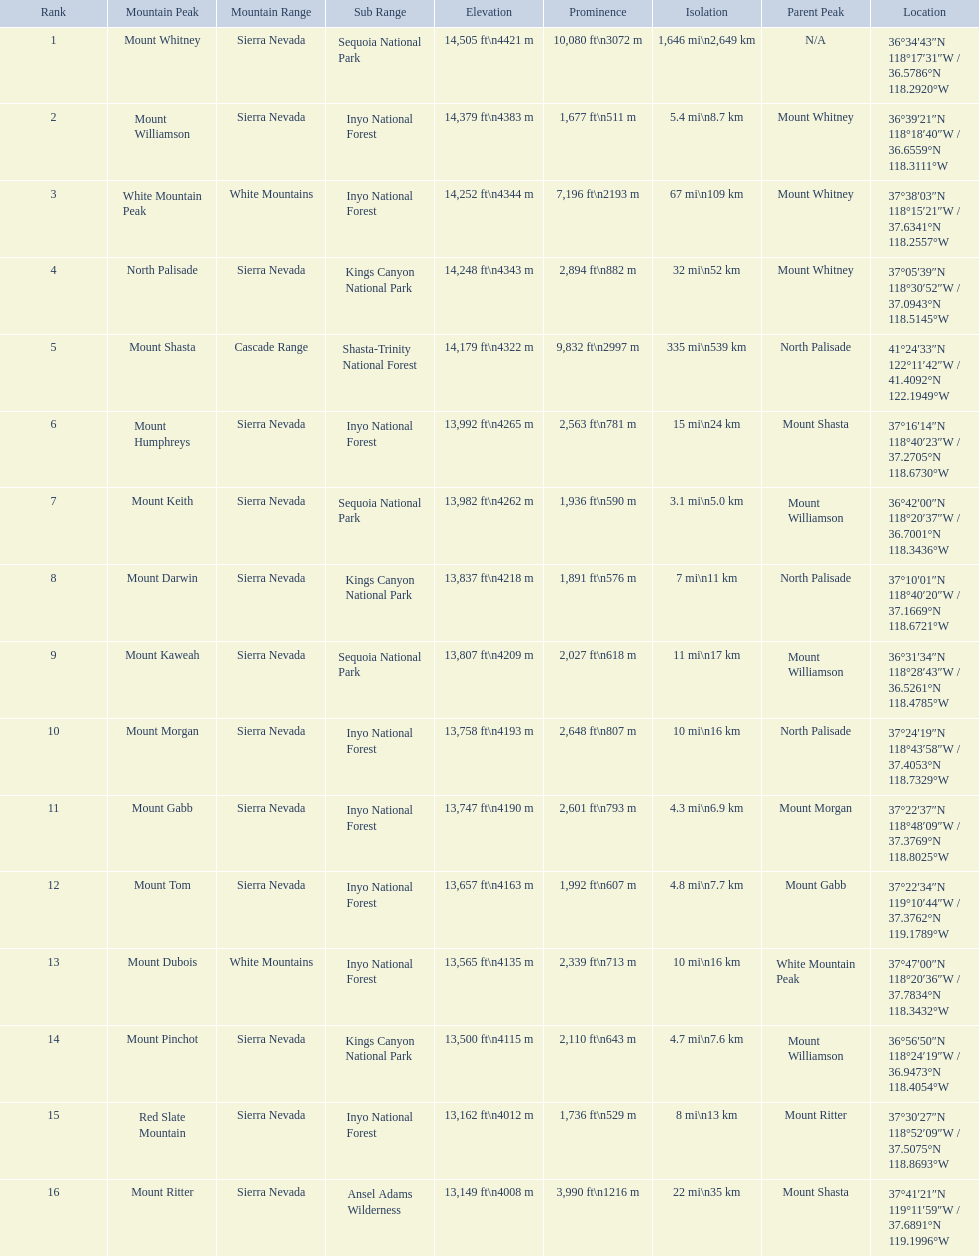Which mountain peak is in the white mountains range? White Mountain Peak. Which mountain is in the sierra nevada range? Mount Whitney. Which mountain is the only one in the cascade range? Mount Shasta. 